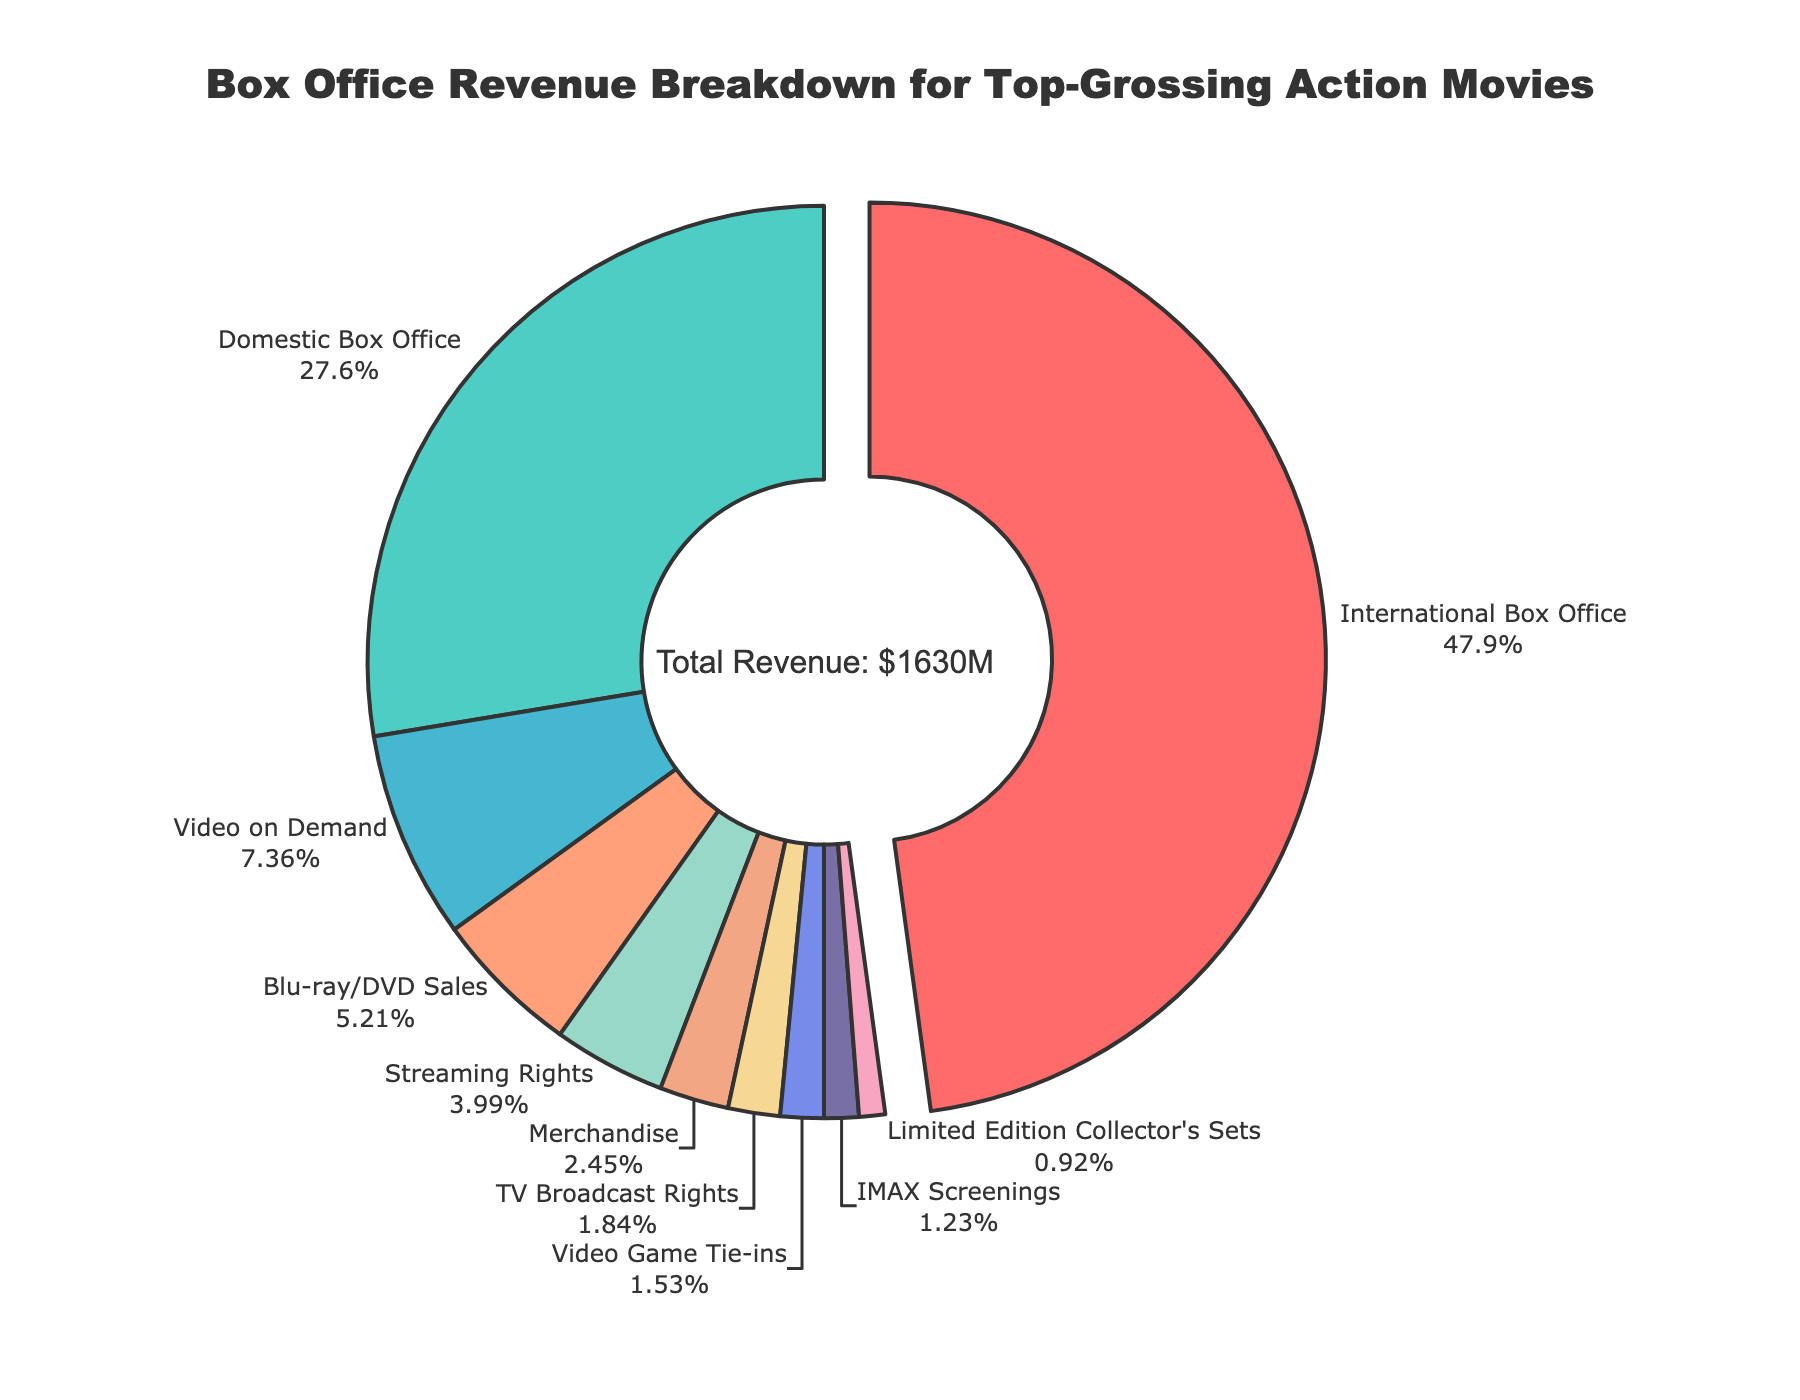What is the largest revenue category? The figure visually highlights the largest revenue category by pulling it out from the center. The "Domestic Box Office" segment is the largest and positioned at the center top with its label and percentage clearly visible outside.
Answer: Domestic Box Office How much more revenue does the International Box Office generate compared to Streaming Rights? To find the difference, subtract the revenue from Streaming Rights ($65M) from the International Box Office ($780M). 780 - 65 = 715.
Answer: $715M What percentage of the total revenue is from Video on Demand sales? Video on Demand segment is labeled with its percentage outside the plot. Identify this segment and read its percentage directly from the chart.
Answer: Approximately 7.18% If you combine Blu-ray/DVD Sales and Merchandise revenues, will they surpass Video on Demand revenue? First, sum the revenues from Blu-ray/DVD Sales ($85M) and Merchandise ($40M) to get 125. Next, compare it with Video on Demand revenue ($120M). Since 125 > 120, they do surpass it.
Answer: Yes Which category contributes the least to the total revenue, and what percentage does it constitute? The smallest segment in the pie chart is the smallest in area and should be labeled with the smallest percentage. The "Limited Edition Collector's Sets" is the smallest, and its percentage is labeled outside the plot.
Answer: Limited Edition Collector's Sets, approximately 0.9% What is the combined percentage of revenue from TV Broadcast Rights, Video Game Tie-ins, and IMAX Screenings? Identify the segments for TV Broadcast Rights (2%), Video Game Tie-ins (1.5%), and IMAX Screenings (1.2%) and sum their percentages. 2 + 1.5 + 1.2 = 4.7%.
Answer: 4.7% Is the revenue from the Domestic Box Office greater than the combined revenue from Blu-ray/DVD Sales, Merchandise, and TV Broadcast Rights? First, sum the revenues from Blu-ray/DVD Sales ($85M), Merchandise ($40M), and TV Broadcast Rights ($30M) to get 155. Since 450 > 155, the Domestic Box Office revenue is indeed greater.
Answer: Yes Which segment has the second-highest revenue, and what color is it represented by? The second-largest segment in the pie chart is the "International Box Office" with its label outside the plot, and it should have a distinct color next to red (used by Domestic Box Office).
Answer: International Box Office, green How does the revenue from IMAX Screenings compare to that from Limited Edition Collector's Sets? The segment for IMAX Screenings ($20M) is larger than that of Limited Edition Collector's Sets ($15M), which should be evident from the relative area of each segment.
Answer: Greater 